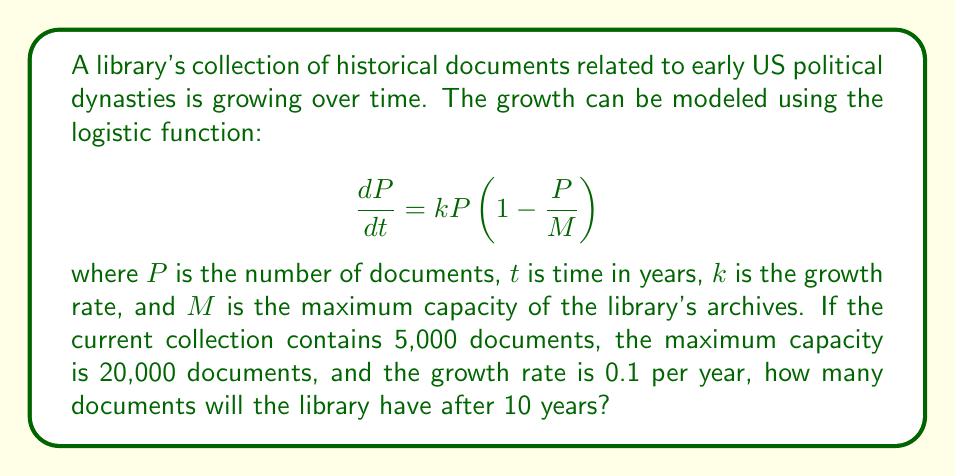Could you help me with this problem? To solve this problem, we need to use the solution to the logistic differential equation:

$$P(t) = \frac{M}{1 + (\frac{M}{P_0} - 1)e^{-kt}}$$

Where:
- $P(t)$ is the number of documents at time $t$
- $M$ is the maximum capacity (20,000 documents)
- $P_0$ is the initial number of documents (5,000)
- $k$ is the growth rate (0.1 per year)
- $t$ is the time in years (10 years)

Let's substitute these values into the equation:

$$P(10) = \frac{20000}{1 + (\frac{20000}{5000} - 1)e^{-0.1 \cdot 10}}$$

Now, let's solve this step-by-step:

1) First, simplify the fraction inside the parentheses:
   $$\frac{20000}{5000} - 1 = 4 - 1 = 3$$

2) Calculate the exponent:
   $$e^{-0.1 \cdot 10} = e^{-1} \approx 0.3679$$

3) Multiply the results from steps 1 and 2:
   $$3 \cdot 0.3679 \approx 1.1037$$

4) Add 1 to the result from step 3:
   $$1 + 1.1037 = 2.1037$$

5) Divide 20,000 by the result from step 4:
   $$\frac{20000}{2.1037} \approx 9507.5$$

6) Round to the nearest whole number, as we can't have fractional documents:
   $$P(10) \approx 9508$$

Therefore, after 10 years, the library will have approximately 9,508 documents in its collection.
Answer: 9,508 documents 